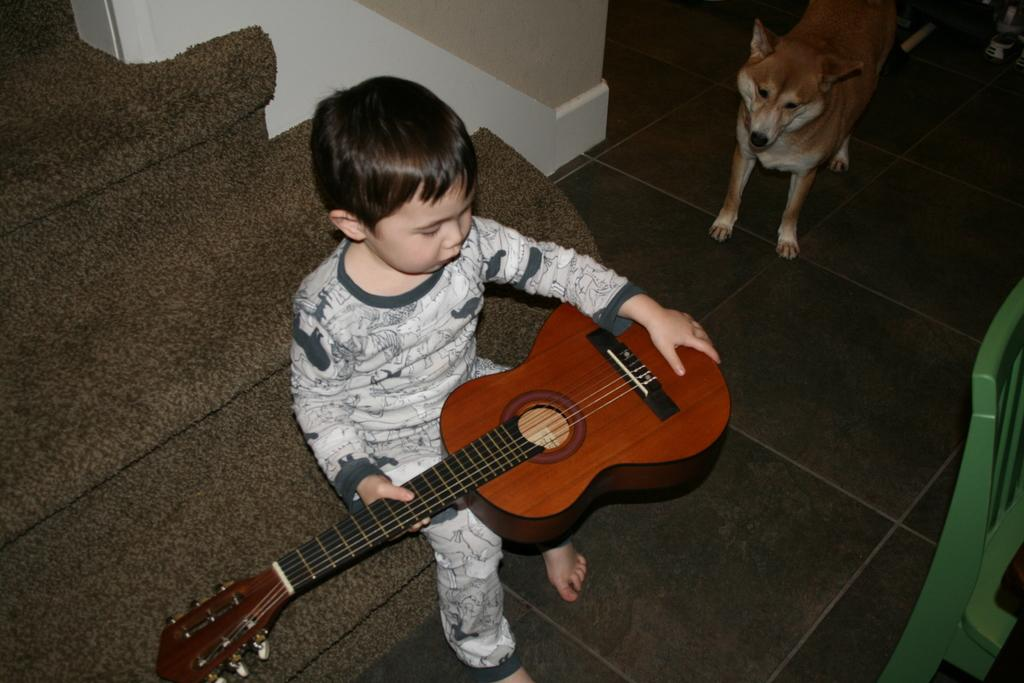What is the kid holding in the image? The kid is holding a guitar. Can you describe the guitar's appearance? The guitar is brown in color. Where is the kid sitting? The kid is sitting on a couch. What other living creature is present in the image? There is a dog beside the kid. Can you describe another piece of furniture in the image? There is a green chair in the image. What type of light can be seen shining on the guitar in the image? There is no specific light source shining on the guitar in the image. Can you describe the leaf on the guitar in the image? There is no leaf present on the guitar in the image. 